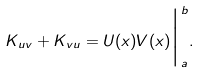<formula> <loc_0><loc_0><loc_500><loc_500>K _ { u v } + K _ { v u } = U ( x ) V ( x ) \Big | _ { a } ^ { b } .</formula> 